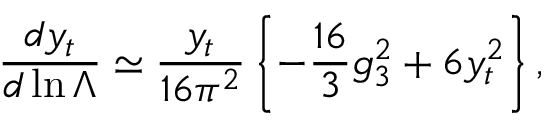Convert formula to latex. <formula><loc_0><loc_0><loc_500><loc_500>\frac { d y _ { t } } { d \ln \Lambda } \simeq \frac { y _ { t } } { 1 6 \pi ^ { 2 } } \left \{ - \frac { 1 6 } { 3 } g _ { 3 } ^ { 2 } + 6 y _ { t } ^ { 2 } \right \} ,</formula> 